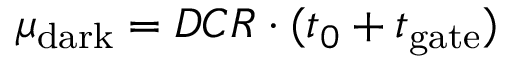Convert formula to latex. <formula><loc_0><loc_0><loc_500><loc_500>\mu _ { d a r k } = D C R \cdot ( t _ { 0 } + t _ { g a t e } )</formula> 